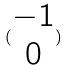<formula> <loc_0><loc_0><loc_500><loc_500>( \begin{matrix} - 1 \\ 0 \end{matrix} )</formula> 